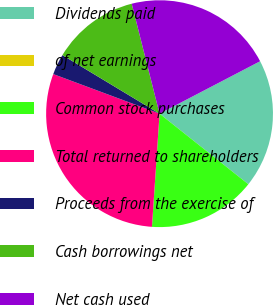Convert chart. <chart><loc_0><loc_0><loc_500><loc_500><pie_chart><fcel>Dividends paid<fcel>of net earnings<fcel>Common stock purchases<fcel>Total returned to shareholders<fcel>Proceeds from the exercise of<fcel>Cash borrowings net<fcel>Net cash used<nl><fcel>18.34%<fcel>0.0%<fcel>15.38%<fcel>29.61%<fcel>2.96%<fcel>12.42%<fcel>21.3%<nl></chart> 